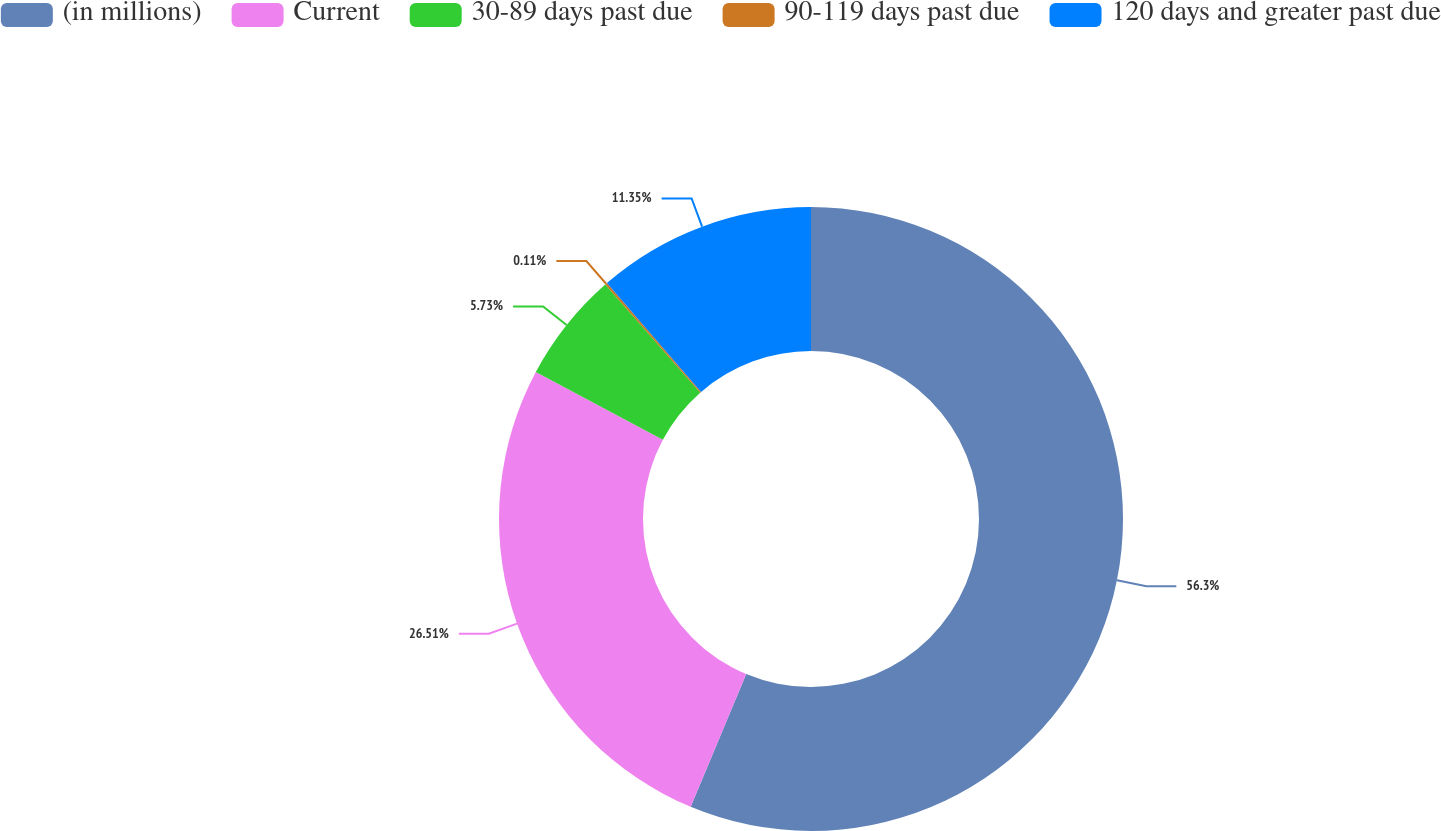Convert chart. <chart><loc_0><loc_0><loc_500><loc_500><pie_chart><fcel>(in millions)<fcel>Current<fcel>30-89 days past due<fcel>90-119 days past due<fcel>120 days and greater past due<nl><fcel>56.3%<fcel>26.51%<fcel>5.73%<fcel>0.11%<fcel>11.35%<nl></chart> 